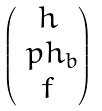Convert formula to latex. <formula><loc_0><loc_0><loc_500><loc_500>\begin{pmatrix} h \\ \ p h _ { b } \\ f \end{pmatrix}</formula> 